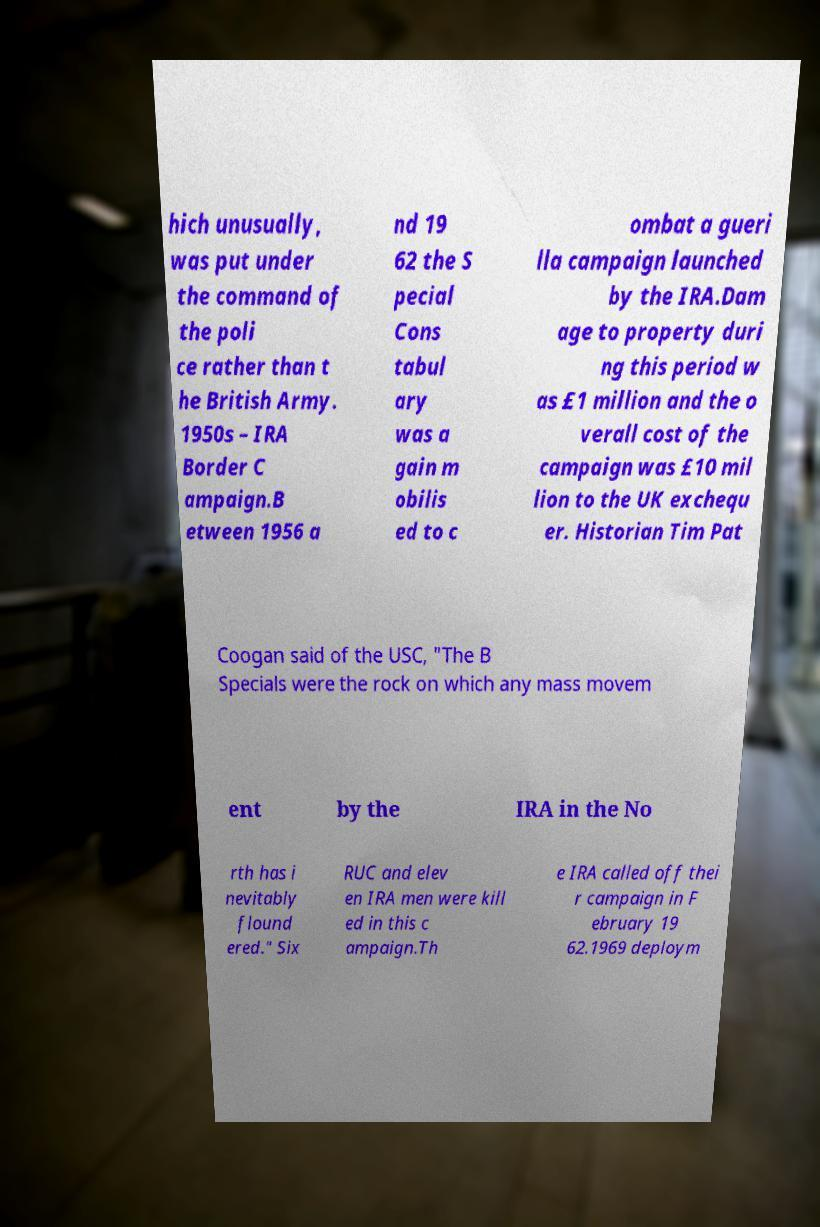What messages or text are displayed in this image? I need them in a readable, typed format. hich unusually, was put under the command of the poli ce rather than t he British Army. 1950s – IRA Border C ampaign.B etween 1956 a nd 19 62 the S pecial Cons tabul ary was a gain m obilis ed to c ombat a gueri lla campaign launched by the IRA.Dam age to property duri ng this period w as £1 million and the o verall cost of the campaign was £10 mil lion to the UK exchequ er. Historian Tim Pat Coogan said of the USC, "The B Specials were the rock on which any mass movem ent by the IRA in the No rth has i nevitably flound ered." Six RUC and elev en IRA men were kill ed in this c ampaign.Th e IRA called off thei r campaign in F ebruary 19 62.1969 deploym 